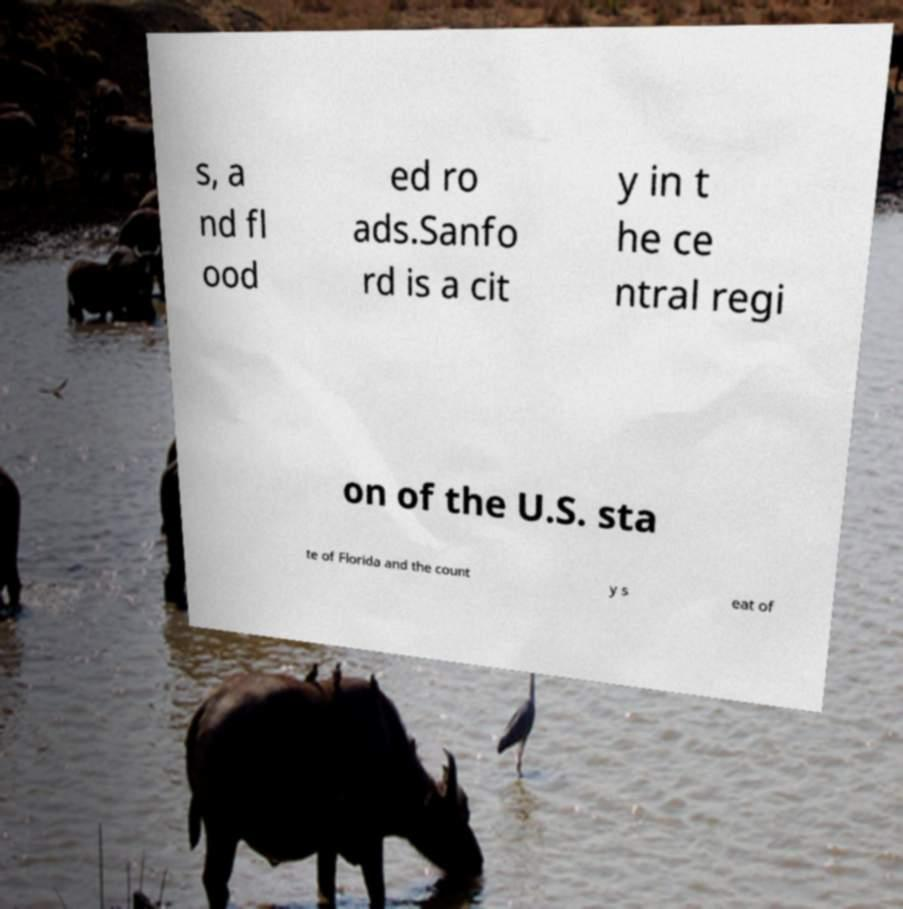Can you read and provide the text displayed in the image?This photo seems to have some interesting text. Can you extract and type it out for me? s, a nd fl ood ed ro ads.Sanfo rd is a cit y in t he ce ntral regi on of the U.S. sta te of Florida and the count y s eat of 